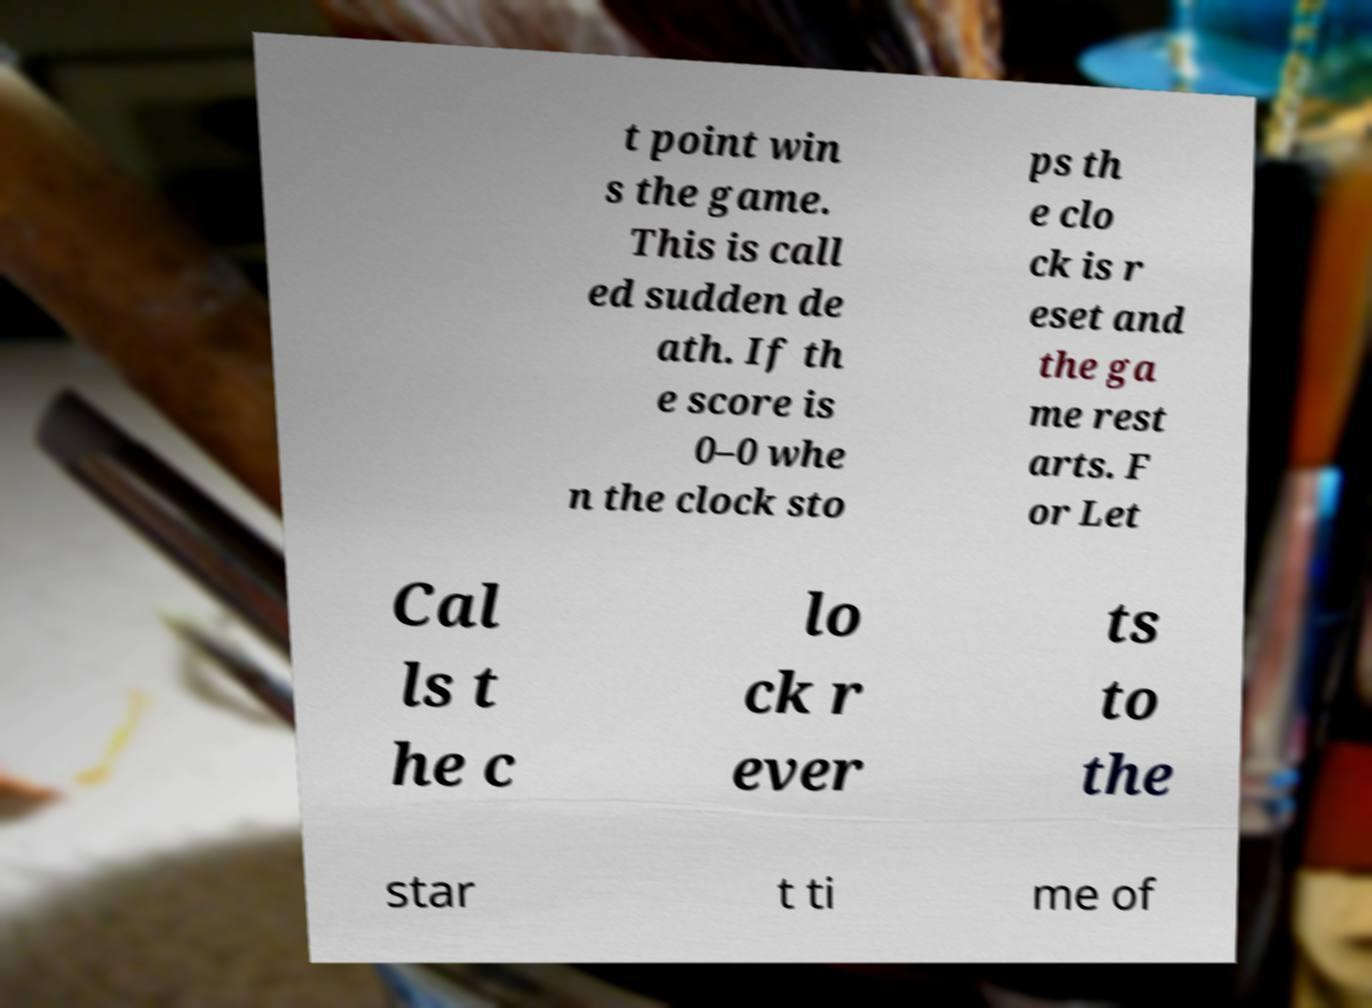Could you assist in decoding the text presented in this image and type it out clearly? t point win s the game. This is call ed sudden de ath. If th e score is 0–0 whe n the clock sto ps th e clo ck is r eset and the ga me rest arts. F or Let Cal ls t he c lo ck r ever ts to the star t ti me of 